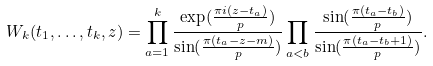<formula> <loc_0><loc_0><loc_500><loc_500>W _ { k } ( t _ { 1 } , \dots , t _ { k } , z ) = \prod _ { a = 1 } ^ { k } \frac { \exp ( \frac { \pi i ( z - t _ { a } ) } { p } ) } { \sin ( \frac { \pi ( t _ { a } - z - m ) } { p } ) } \prod _ { a < b } \frac { \sin ( \frac { \pi ( t _ { a } - t _ { b } ) } { p } ) } { \sin ( \frac { \pi ( t _ { a } - t _ { b } + 1 ) } { p } ) } .</formula> 